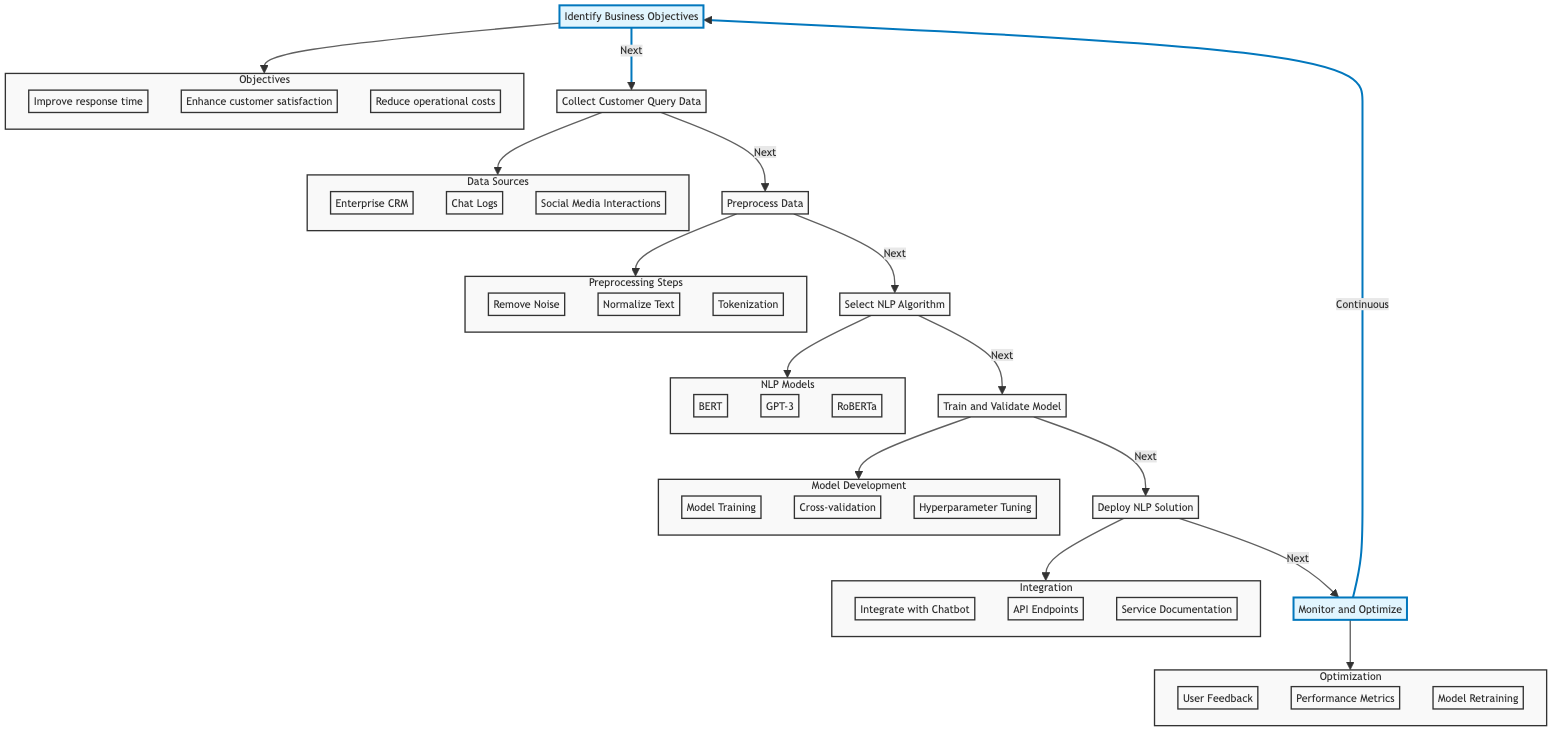What is the first step in the diagram? The first step in the diagram is "Identify Business Objectives," which is the starting node leading to the next instruction.
Answer: Identify Business Objectives How many substeps are in the "Collect Customer Query Data" step? The "Collect Customer Query Data" step includes three substeps: "Enterprise CRM," "Chat Logs," and "Social Media Interactions."
Answer: Three What are the two highlighted nodes in the diagram? The highlighted nodes are "Identify Business Objectives" and "Monitor and Optimize," which have been emphasized for their continuous role in the process.
Answer: Identify Business Objectives, Monitor and Optimize What is the last step before the "Deploy NLP Solution"? The last step before "Deploy NLP Solution" is "Train and Validate Model," which is where the model is built and examined before implementation.
Answer: Train and Validate Model Which substep involves refining the model based on user experience? The substep that involves refining the model based on user experience is "User Feedback," which helps assess and improve the solution after deployment.
Answer: User Feedback What is the relationship between "Select NLP Algorithm" and "Preprocess Data"? The relationship is sequential; "Preprocess Data" must be completed before moving on to "Select NLP Algorithm," indicating the logical flow of the process.
Answer: Sequential Which substep belongs to the "Integration" category? The substep that belongs to the "Integration" category is "Integrate with Chatbot," which outlines the action of implementing the trained model into the existing system.
Answer: Integrate with Chatbot How does the diagram indicate the cyclical nature of the process? The diagram indicates the cyclical nature through the arrows connecting "Monitor and Optimize" back to "Identify Business Objectives," illustrating continuous improvement.
Answer: Continuous 